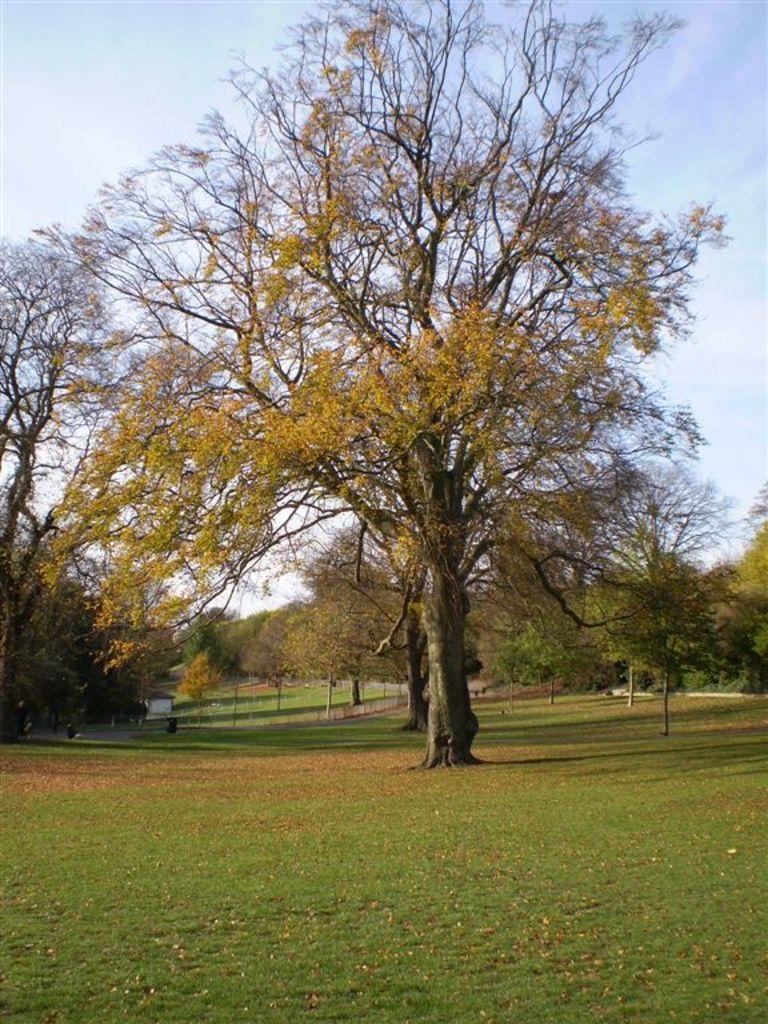Please provide a concise description of this image. In this picture we can see the tree in the garden. Behind we can see many trees. 